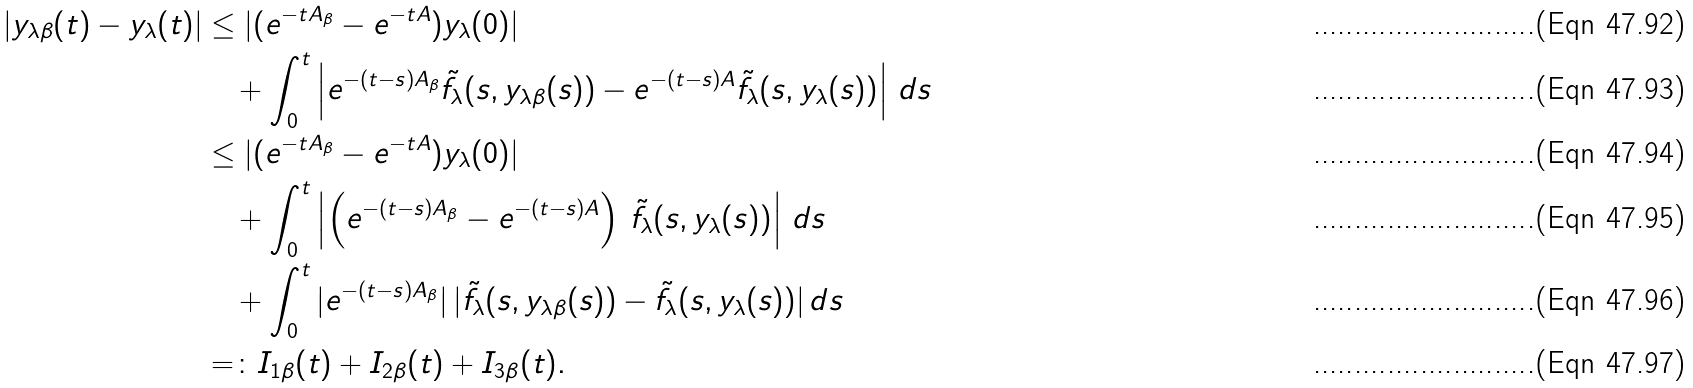Convert formula to latex. <formula><loc_0><loc_0><loc_500><loc_500>| y _ { \lambda \beta } ( t ) - y _ { \lambda } ( t ) | & \leq | ( e ^ { - t A _ { \beta } } - e ^ { - t A } ) y _ { \lambda } ( 0 ) | \\ & \quad + \int _ { 0 } ^ { t } \left | e ^ { - ( t - s ) A _ { \beta } } \tilde { f } _ { \lambda } ( s , y _ { \lambda \beta } ( s ) ) - e ^ { - ( t - s ) A } \tilde { f } _ { \lambda } ( s , y _ { \lambda } ( s ) ) \right | \, d s \\ & \leq | ( e ^ { - t A _ { \beta } } - e ^ { - t A } ) y _ { \lambda } ( 0 ) | \\ & \quad + \int _ { 0 } ^ { t } \left | \left ( e ^ { - ( t - s ) A _ { \beta } } - e ^ { - ( t - s ) A } \right ) \, \tilde { f } _ { \lambda } ( s , y _ { \lambda } ( s ) ) \right | \, d s \\ & \quad + \int _ { 0 } ^ { t } | e ^ { - ( t - s ) A _ { \beta } } | \, | \tilde { f } _ { \lambda } ( s , y _ { \lambda \beta } ( s ) ) - \tilde { f } _ { \lambda } ( s , y _ { \lambda } ( s ) ) | \, d s \\ & = \colon I _ { 1 \beta } ( t ) + I _ { 2 \beta } ( t ) + I _ { 3 \beta } ( t ) .</formula> 